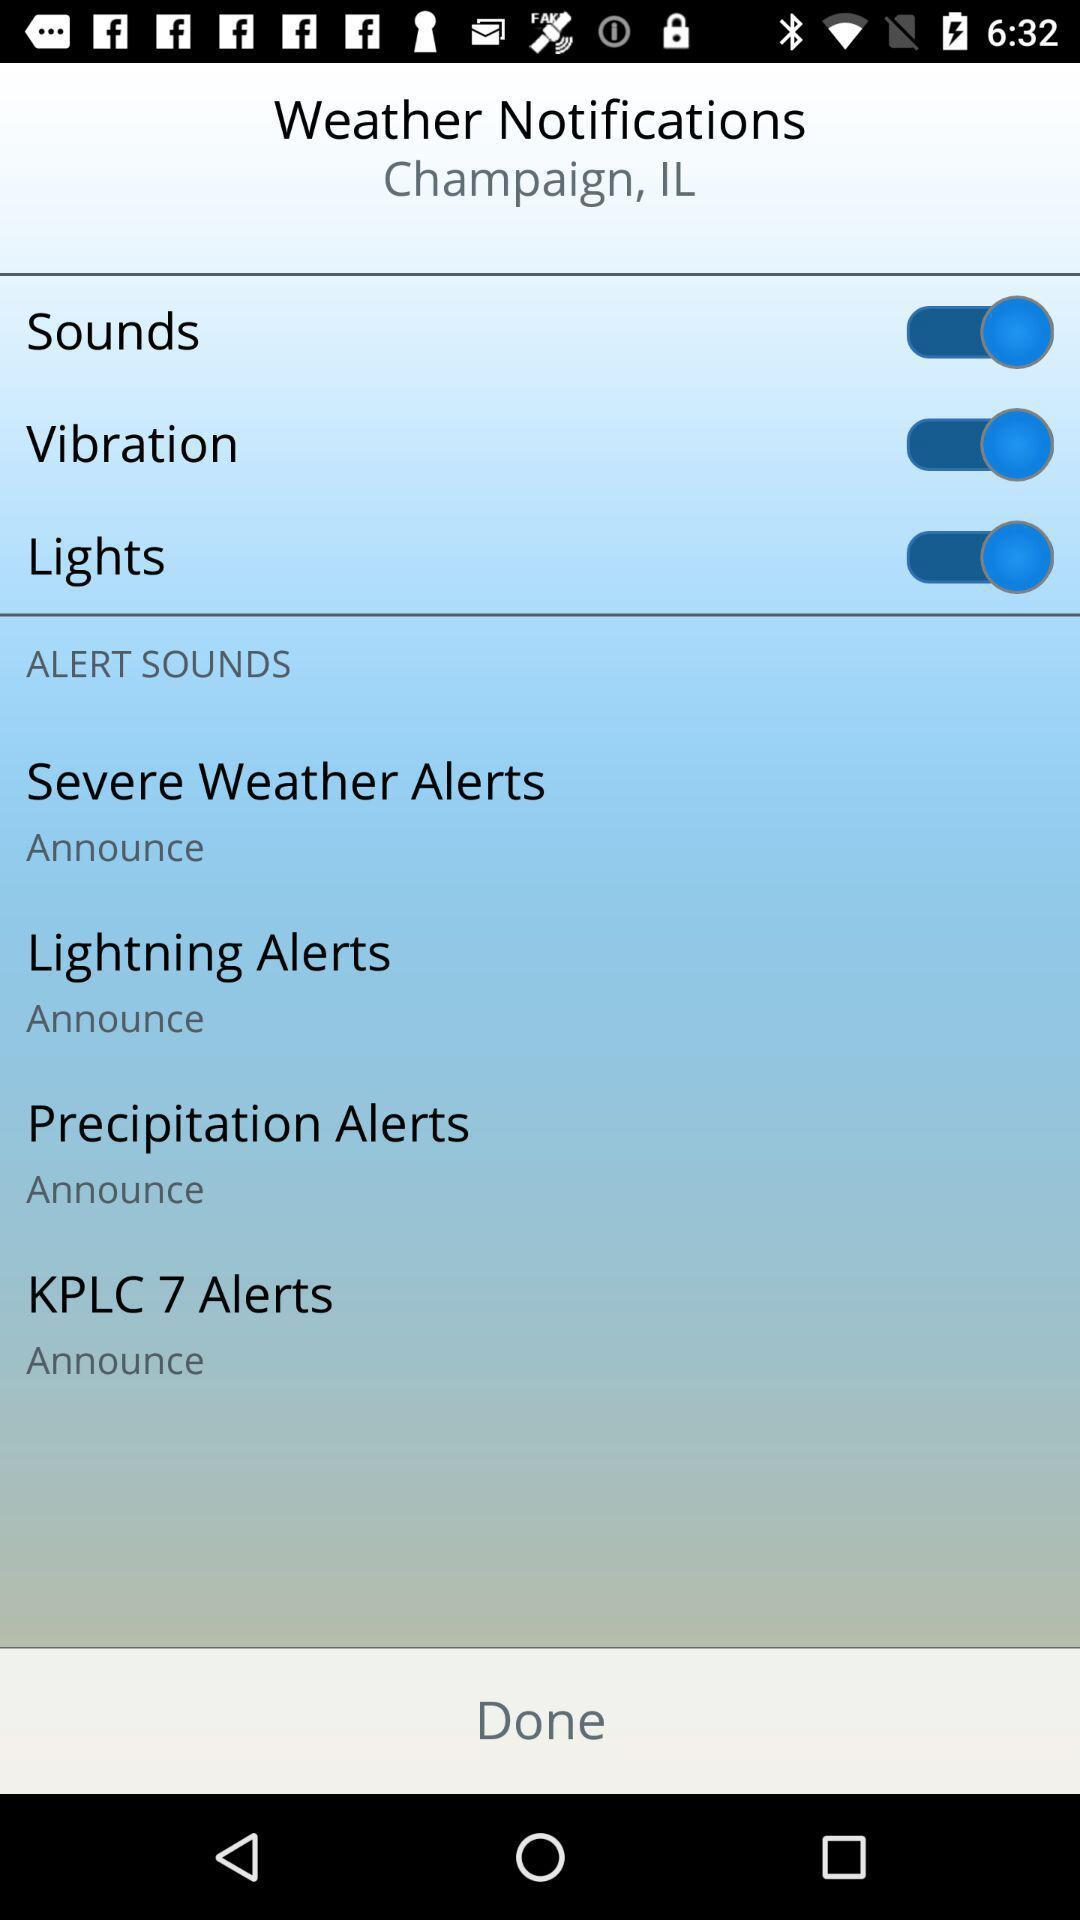What is the status of the "Sounds"? The status is "on". 